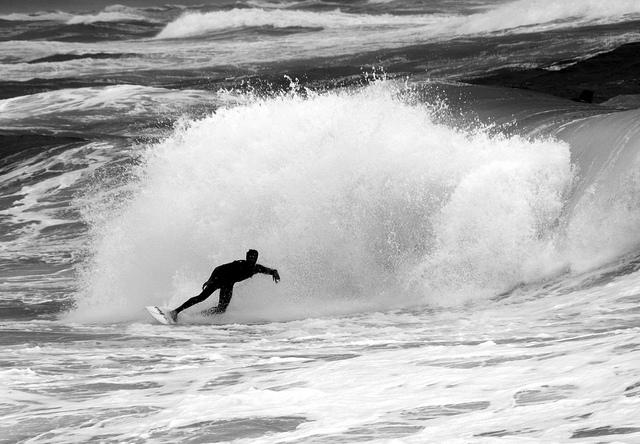What is this person doing?
Be succinct. Surfing. IS the man in the ocean?
Short answer required. Yes. What color is the photo?
Answer briefly. Black and white. 